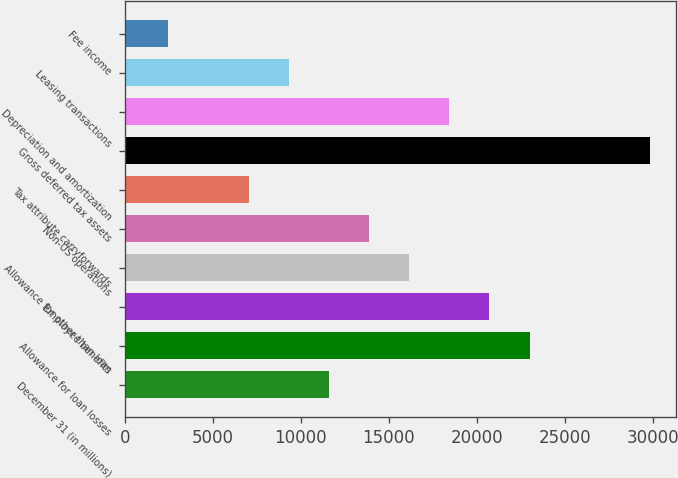Convert chart. <chart><loc_0><loc_0><loc_500><loc_500><bar_chart><fcel>December 31 (in millions)<fcel>Allowance for loan losses<fcel>Employee benefits<fcel>Allowance for other than loan<fcel>Non-US operations<fcel>Tax attribute carryforwards<fcel>Gross deferred tax assets<fcel>Depreciation and amortization<fcel>Leasing transactions<fcel>Fee income<nl><fcel>11605<fcel>23008<fcel>20727.4<fcel>16166.2<fcel>13885.6<fcel>7043.8<fcel>29849.8<fcel>18446.8<fcel>9324.4<fcel>2482.6<nl></chart> 